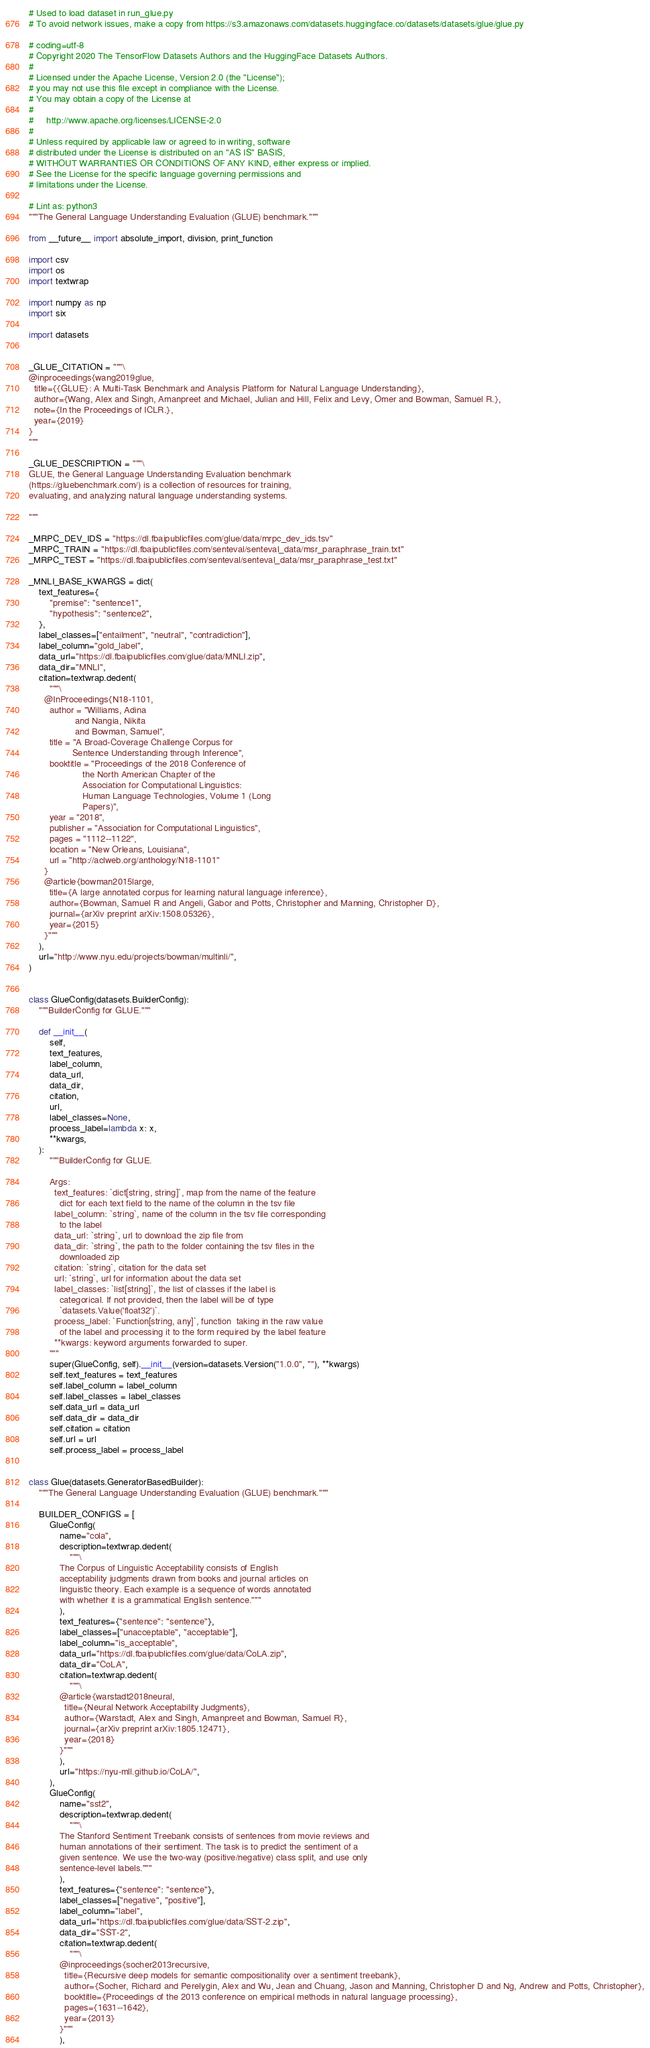<code> <loc_0><loc_0><loc_500><loc_500><_Python_># Used to load dataset in run_glue.py
# To avoid network issues, make a copy from https://s3.amazonaws.com/datasets.huggingface.co/datasets/datasets/glue/glue.py

# coding=utf-8
# Copyright 2020 The TensorFlow Datasets Authors and the HuggingFace Datasets Authors.
#
# Licensed under the Apache License, Version 2.0 (the "License");
# you may not use this file except in compliance with the License.
# You may obtain a copy of the License at
#
#     http://www.apache.org/licenses/LICENSE-2.0
#
# Unless required by applicable law or agreed to in writing, software
# distributed under the License is distributed on an "AS IS" BASIS,
# WITHOUT WARRANTIES OR CONDITIONS OF ANY KIND, either express or implied.
# See the License for the specific language governing permissions and
# limitations under the License.

# Lint as: python3
"""The General Language Understanding Evaluation (GLUE) benchmark."""

from __future__ import absolute_import, division, print_function

import csv
import os
import textwrap

import numpy as np
import six

import datasets


_GLUE_CITATION = """\
@inproceedings{wang2019glue,
  title={{GLUE}: A Multi-Task Benchmark and Analysis Platform for Natural Language Understanding},
  author={Wang, Alex and Singh, Amanpreet and Michael, Julian and Hill, Felix and Levy, Omer and Bowman, Samuel R.},
  note={In the Proceedings of ICLR.},
  year={2019}
}
"""

_GLUE_DESCRIPTION = """\
GLUE, the General Language Understanding Evaluation benchmark
(https://gluebenchmark.com/) is a collection of resources for training,
evaluating, and analyzing natural language understanding systems.

"""

_MRPC_DEV_IDS = "https://dl.fbaipublicfiles.com/glue/data/mrpc_dev_ids.tsv"
_MRPC_TRAIN = "https://dl.fbaipublicfiles.com/senteval/senteval_data/msr_paraphrase_train.txt"
_MRPC_TEST = "https://dl.fbaipublicfiles.com/senteval/senteval_data/msr_paraphrase_test.txt"

_MNLI_BASE_KWARGS = dict(
    text_features={
        "premise": "sentence1",
        "hypothesis": "sentence2",
    },
    label_classes=["entailment", "neutral", "contradiction"],
    label_column="gold_label",
    data_url="https://dl.fbaipublicfiles.com/glue/data/MNLI.zip",
    data_dir="MNLI",
    citation=textwrap.dedent(
        """\
      @InProceedings{N18-1101,
        author = "Williams, Adina
                  and Nangia, Nikita
                  and Bowman, Samuel",
        title = "A Broad-Coverage Challenge Corpus for
                 Sentence Understanding through Inference",
        booktitle = "Proceedings of the 2018 Conference of
                     the North American Chapter of the
                     Association for Computational Linguistics:
                     Human Language Technologies, Volume 1 (Long
                     Papers)",
        year = "2018",
        publisher = "Association for Computational Linguistics",
        pages = "1112--1122",
        location = "New Orleans, Louisiana",
        url = "http://aclweb.org/anthology/N18-1101"
      }
      @article{bowman2015large,
        title={A large annotated corpus for learning natural language inference},
        author={Bowman, Samuel R and Angeli, Gabor and Potts, Christopher and Manning, Christopher D},
        journal={arXiv preprint arXiv:1508.05326},
        year={2015}
      }"""
    ),
    url="http://www.nyu.edu/projects/bowman/multinli/",
)


class GlueConfig(datasets.BuilderConfig):
    """BuilderConfig for GLUE."""

    def __init__(
        self,
        text_features,
        label_column,
        data_url,
        data_dir,
        citation,
        url,
        label_classes=None,
        process_label=lambda x: x,
        **kwargs,
    ):
        """BuilderConfig for GLUE.

        Args:
          text_features: `dict[string, string]`, map from the name of the feature
            dict for each text field to the name of the column in the tsv file
          label_column: `string`, name of the column in the tsv file corresponding
            to the label
          data_url: `string`, url to download the zip file from
          data_dir: `string`, the path to the folder containing the tsv files in the
            downloaded zip
          citation: `string`, citation for the data set
          url: `string`, url for information about the data set
          label_classes: `list[string]`, the list of classes if the label is
            categorical. If not provided, then the label will be of type
            `datasets.Value('float32')`.
          process_label: `Function[string, any]`, function  taking in the raw value
            of the label and processing it to the form required by the label feature
          **kwargs: keyword arguments forwarded to super.
        """
        super(GlueConfig, self).__init__(version=datasets.Version("1.0.0", ""), **kwargs)
        self.text_features = text_features
        self.label_column = label_column
        self.label_classes = label_classes
        self.data_url = data_url
        self.data_dir = data_dir
        self.citation = citation
        self.url = url
        self.process_label = process_label


class Glue(datasets.GeneratorBasedBuilder):
    """The General Language Understanding Evaluation (GLUE) benchmark."""

    BUILDER_CONFIGS = [
        GlueConfig(
            name="cola",
            description=textwrap.dedent(
                """\
            The Corpus of Linguistic Acceptability consists of English
            acceptability judgments drawn from books and journal articles on
            linguistic theory. Each example is a sequence of words annotated
            with whether it is a grammatical English sentence."""
            ),
            text_features={"sentence": "sentence"},
            label_classes=["unacceptable", "acceptable"],
            label_column="is_acceptable",
            data_url="https://dl.fbaipublicfiles.com/glue/data/CoLA.zip",
            data_dir="CoLA",
            citation=textwrap.dedent(
                """\
            @article{warstadt2018neural,
              title={Neural Network Acceptability Judgments},
              author={Warstadt, Alex and Singh, Amanpreet and Bowman, Samuel R},
              journal={arXiv preprint arXiv:1805.12471},
              year={2018}
            }"""
            ),
            url="https://nyu-mll.github.io/CoLA/",
        ),
        GlueConfig(
            name="sst2",
            description=textwrap.dedent(
                """\
            The Stanford Sentiment Treebank consists of sentences from movie reviews and
            human annotations of their sentiment. The task is to predict the sentiment of a
            given sentence. We use the two-way (positive/negative) class split, and use only
            sentence-level labels."""
            ),
            text_features={"sentence": "sentence"},
            label_classes=["negative", "positive"],
            label_column="label",
            data_url="https://dl.fbaipublicfiles.com/glue/data/SST-2.zip",
            data_dir="SST-2",
            citation=textwrap.dedent(
                """\
            @inproceedings{socher2013recursive,
              title={Recursive deep models for semantic compositionality over a sentiment treebank},
              author={Socher, Richard and Perelygin, Alex and Wu, Jean and Chuang, Jason and Manning, Christopher D and Ng, Andrew and Potts, Christopher},
              booktitle={Proceedings of the 2013 conference on empirical methods in natural language processing},
              pages={1631--1642},
              year={2013}
            }"""
            ),</code> 